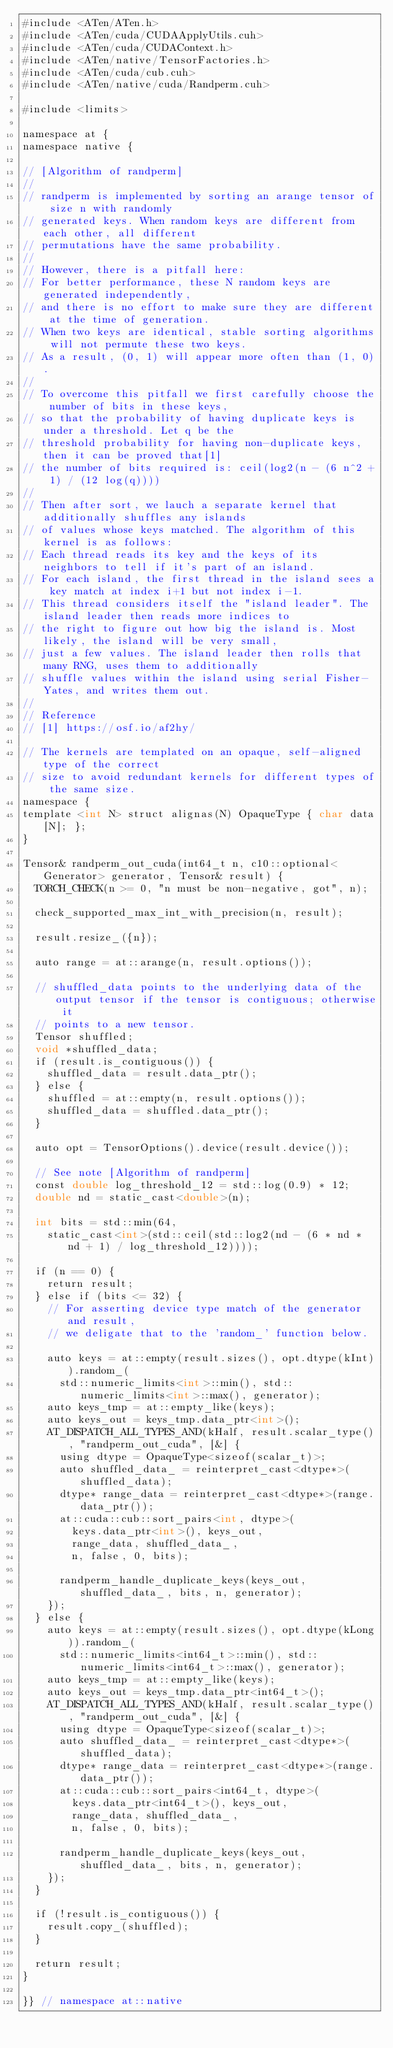<code> <loc_0><loc_0><loc_500><loc_500><_Cuda_>#include <ATen/ATen.h>
#include <ATen/cuda/CUDAApplyUtils.cuh>
#include <ATen/cuda/CUDAContext.h>
#include <ATen/native/TensorFactories.h>
#include <ATen/cuda/cub.cuh>
#include <ATen/native/cuda/Randperm.cuh>

#include <limits>

namespace at {
namespace native {

// [Algorithm of randperm]
//
// randperm is implemented by sorting an arange tensor of size n with randomly
// generated keys. When random keys are different from each other, all different
// permutations have the same probability.
//
// However, there is a pitfall here:
// For better performance, these N random keys are generated independently,
// and there is no effort to make sure they are different at the time of generation.
// When two keys are identical, stable sorting algorithms will not permute these two keys.
// As a result, (0, 1) will appear more often than (1, 0).
//
// To overcome this pitfall we first carefully choose the number of bits in these keys,
// so that the probability of having duplicate keys is under a threshold. Let q be the
// threshold probability for having non-duplicate keys, then it can be proved that[1]
// the number of bits required is: ceil(log2(n - (6 n^2 + 1) / (12 log(q))))
//
// Then after sort, we lauch a separate kernel that additionally shuffles any islands
// of values whose keys matched. The algorithm of this kernel is as follows:
// Each thread reads its key and the keys of its neighbors to tell if it's part of an island.
// For each island, the first thread in the island sees a key match at index i+1 but not index i-1.
// This thread considers itself the "island leader". The island leader then reads more indices to
// the right to figure out how big the island is. Most likely, the island will be very small,
// just a few values. The island leader then rolls that many RNG, uses them to additionally
// shuffle values within the island using serial Fisher-Yates, and writes them out.
//
// Reference
// [1] https://osf.io/af2hy/

// The kernels are templated on an opaque, self-aligned type of the correct
// size to avoid redundant kernels for different types of the same size.
namespace {
template <int N> struct alignas(N) OpaqueType { char data[N]; };
}

Tensor& randperm_out_cuda(int64_t n, c10::optional<Generator> generator, Tensor& result) {
  TORCH_CHECK(n >= 0, "n must be non-negative, got", n);

  check_supported_max_int_with_precision(n, result);

  result.resize_({n});

  auto range = at::arange(n, result.options());

  // shuffled_data points to the underlying data of the output tensor if the tensor is contiguous; otherwise it
  // points to a new tensor.
  Tensor shuffled;
  void *shuffled_data;
  if (result.is_contiguous()) {
    shuffled_data = result.data_ptr();
  } else {
    shuffled = at::empty(n, result.options());
    shuffled_data = shuffled.data_ptr();
  }

  auto opt = TensorOptions().device(result.device());

  // See note [Algorithm of randperm]
  const double log_threshold_12 = std::log(0.9) * 12;
  double nd = static_cast<double>(n);

  int bits = std::min(64,
    static_cast<int>(std::ceil(std::log2(nd - (6 * nd * nd + 1) / log_threshold_12))));

  if (n == 0) {
    return result;
  } else if (bits <= 32) {
    // For asserting device type match of the generator and result,
    // we deligate that to the 'random_' function below.

    auto keys = at::empty(result.sizes(), opt.dtype(kInt)).random_(
      std::numeric_limits<int>::min(), std::numeric_limits<int>::max(), generator);
    auto keys_tmp = at::empty_like(keys);
    auto keys_out = keys_tmp.data_ptr<int>();
    AT_DISPATCH_ALL_TYPES_AND(kHalf, result.scalar_type(), "randperm_out_cuda", [&] {
      using dtype = OpaqueType<sizeof(scalar_t)>;
      auto shuffled_data_ = reinterpret_cast<dtype*>(shuffled_data);
      dtype* range_data = reinterpret_cast<dtype*>(range.data_ptr());
      at::cuda::cub::sort_pairs<int, dtype>(
        keys.data_ptr<int>(), keys_out,
        range_data, shuffled_data_,
        n, false, 0, bits);

      randperm_handle_duplicate_keys(keys_out, shuffled_data_, bits, n, generator);
    });
  } else {
    auto keys = at::empty(result.sizes(), opt.dtype(kLong)).random_(
      std::numeric_limits<int64_t>::min(), std::numeric_limits<int64_t>::max(), generator);
    auto keys_tmp = at::empty_like(keys);
    auto keys_out = keys_tmp.data_ptr<int64_t>();
    AT_DISPATCH_ALL_TYPES_AND(kHalf, result.scalar_type(), "randperm_out_cuda", [&] {
      using dtype = OpaqueType<sizeof(scalar_t)>;
      auto shuffled_data_ = reinterpret_cast<dtype*>(shuffled_data);
      dtype* range_data = reinterpret_cast<dtype*>(range.data_ptr());
      at::cuda::cub::sort_pairs<int64_t, dtype>(
        keys.data_ptr<int64_t>(), keys_out,
        range_data, shuffled_data_,
        n, false, 0, bits);

      randperm_handle_duplicate_keys(keys_out, shuffled_data_, bits, n, generator);
    });
  }

  if (!result.is_contiguous()) {
    result.copy_(shuffled);
  }

  return result;
}

}} // namespace at::native
</code> 